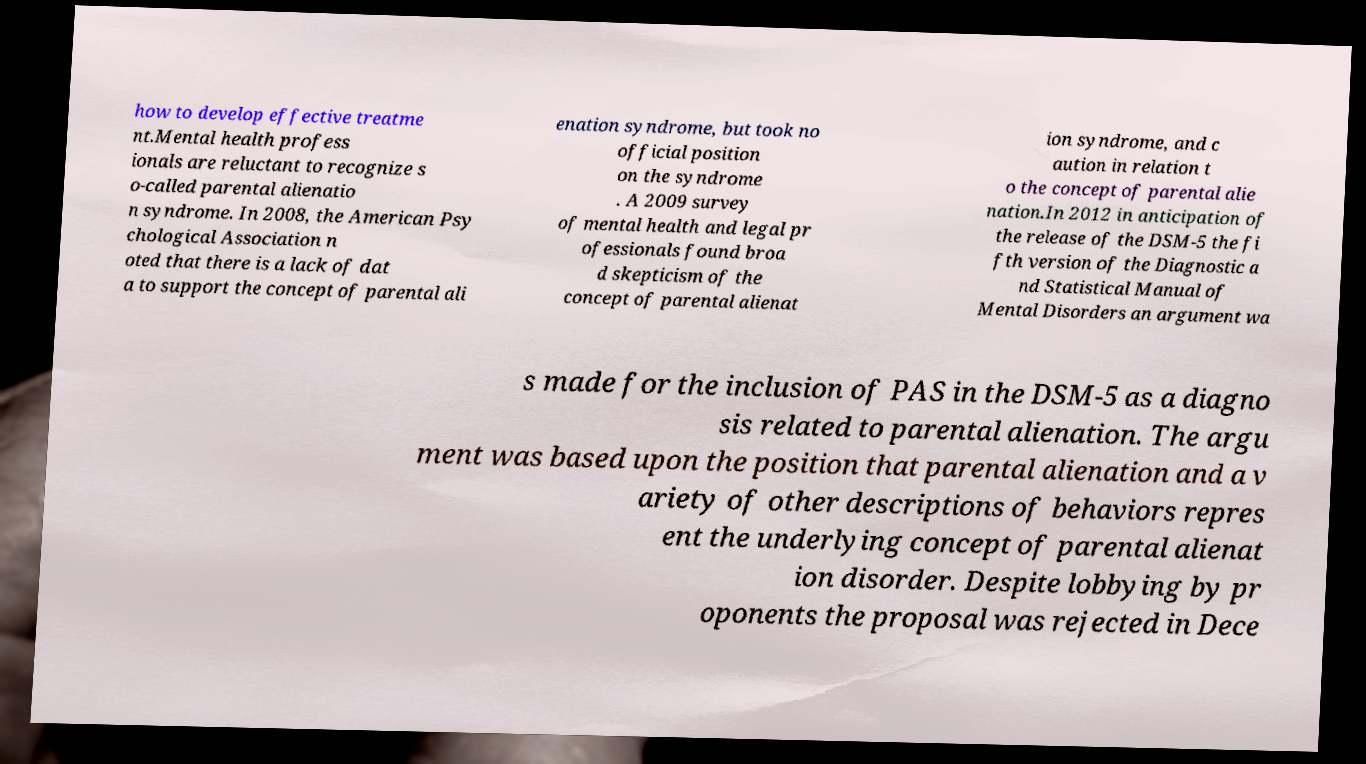For documentation purposes, I need the text within this image transcribed. Could you provide that? how to develop effective treatme nt.Mental health profess ionals are reluctant to recognize s o-called parental alienatio n syndrome. In 2008, the American Psy chological Association n oted that there is a lack of dat a to support the concept of parental ali enation syndrome, but took no official position on the syndrome . A 2009 survey of mental health and legal pr ofessionals found broa d skepticism of the concept of parental alienat ion syndrome, and c aution in relation t o the concept of parental alie nation.In 2012 in anticipation of the release of the DSM-5 the fi fth version of the Diagnostic a nd Statistical Manual of Mental Disorders an argument wa s made for the inclusion of PAS in the DSM-5 as a diagno sis related to parental alienation. The argu ment was based upon the position that parental alienation and a v ariety of other descriptions of behaviors repres ent the underlying concept of parental alienat ion disorder. Despite lobbying by pr oponents the proposal was rejected in Dece 